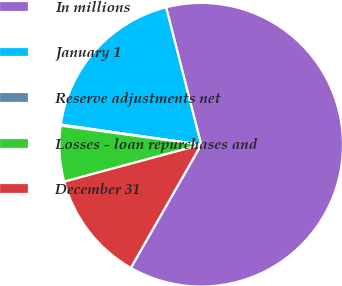Convert chart. <chart><loc_0><loc_0><loc_500><loc_500><pie_chart><fcel>In millions<fcel>January 1<fcel>Reserve adjustments net<fcel>Losses - loan repurchases and<fcel>December 31<nl><fcel>62.24%<fcel>18.76%<fcel>0.12%<fcel>6.34%<fcel>12.55%<nl></chart> 